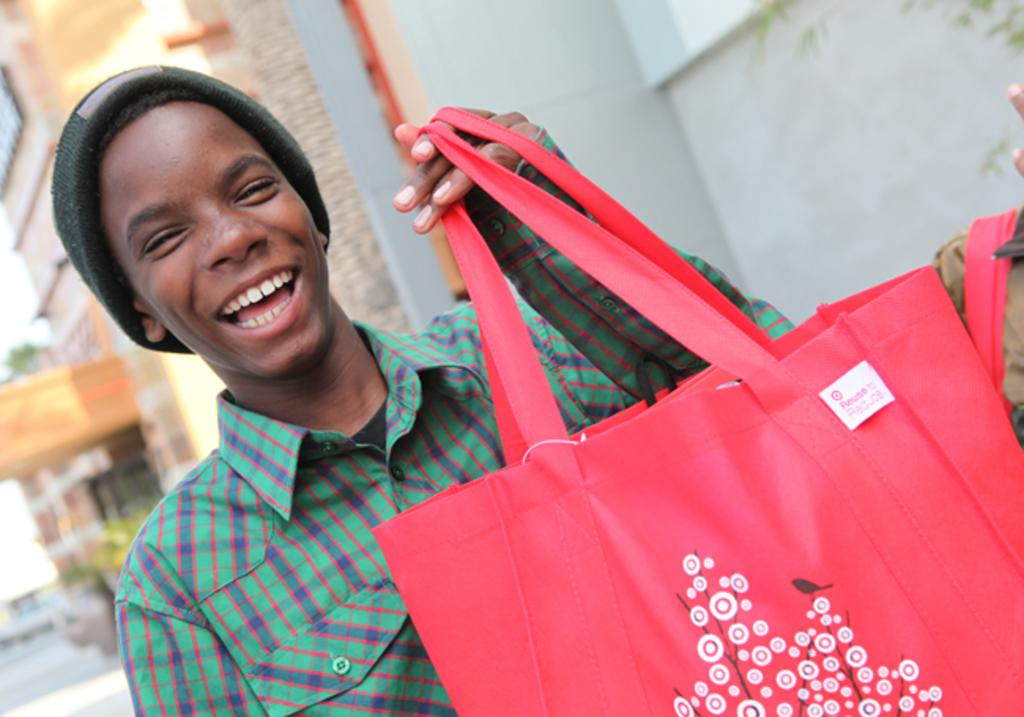What is the main subject of the image? The main subject of the image is a man. What is the man wearing on his upper body? The man is wearing a green shirt. What is the man wearing on his head? The man is wearing a green cap. What is the man holding in the image? The man is holding a red bag. What is the man's facial expression in the image? The man is smiling. What can be seen in the background of the image? There is a building in the background of the image. How many sisters does the man have in the image? There is no information about the man's sisters in the image. 